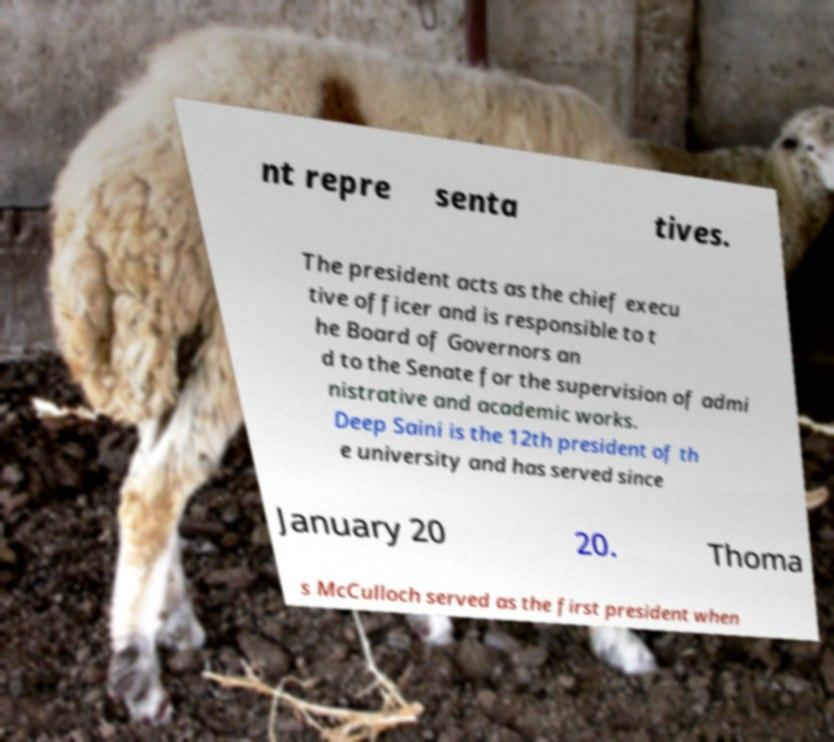What messages or text are displayed in this image? I need them in a readable, typed format. nt repre senta tives. The president acts as the chief execu tive officer and is responsible to t he Board of Governors an d to the Senate for the supervision of admi nistrative and academic works. Deep Saini is the 12th president of th e university and has served since January 20 20. Thoma s McCulloch served as the first president when 